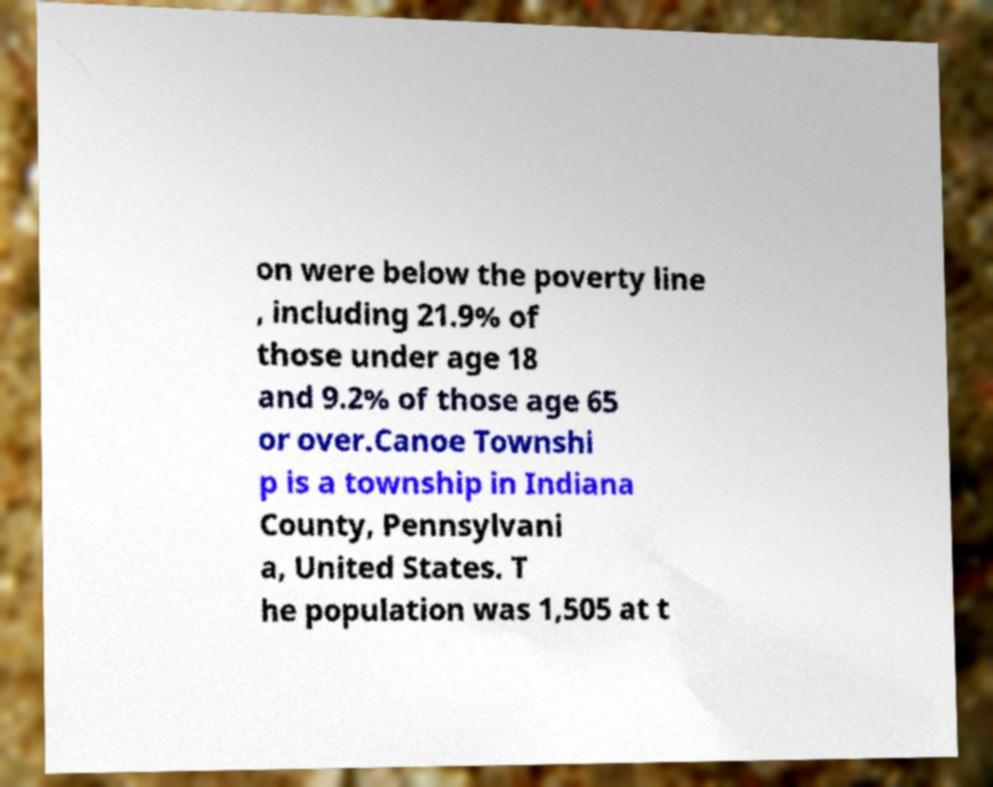For documentation purposes, I need the text within this image transcribed. Could you provide that? on were below the poverty line , including 21.9% of those under age 18 and 9.2% of those age 65 or over.Canoe Townshi p is a township in Indiana County, Pennsylvani a, United States. T he population was 1,505 at t 